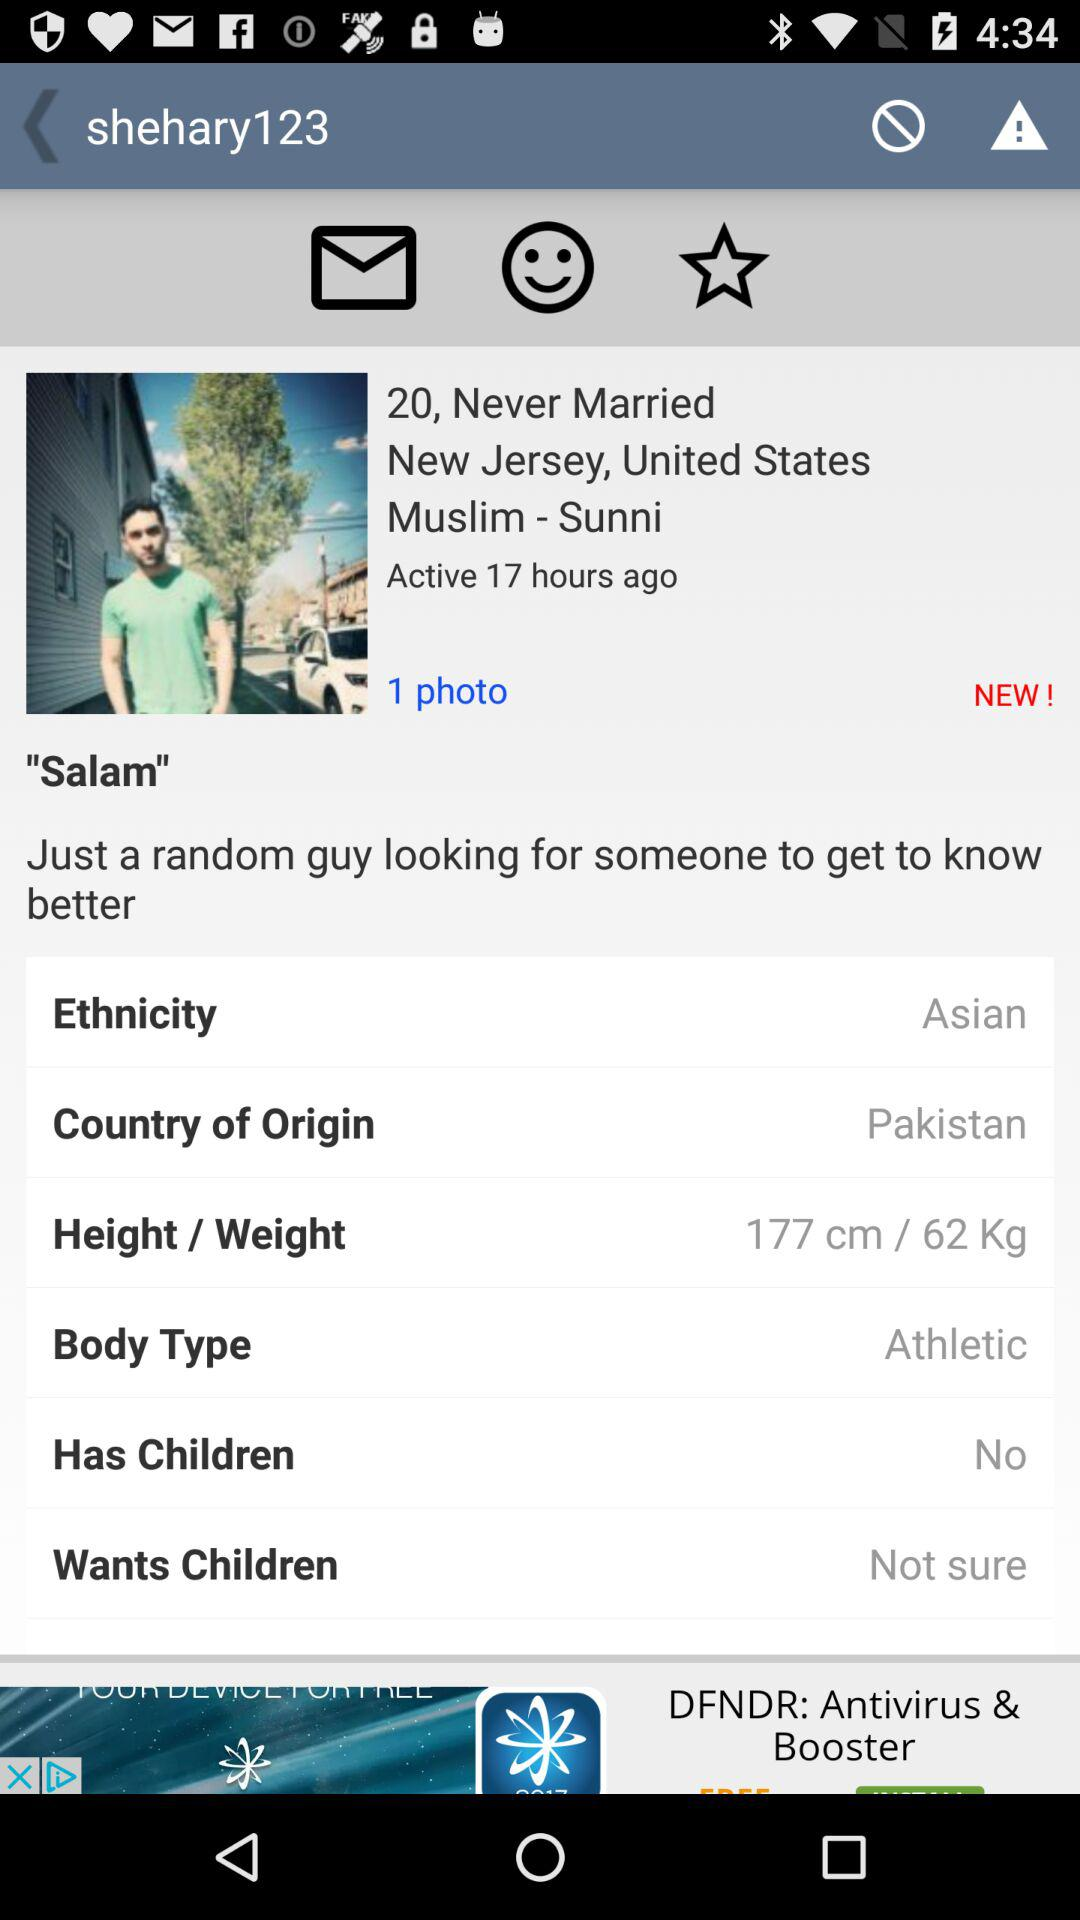What is the address of "shehary123"? The address is New Jersey, United States. 